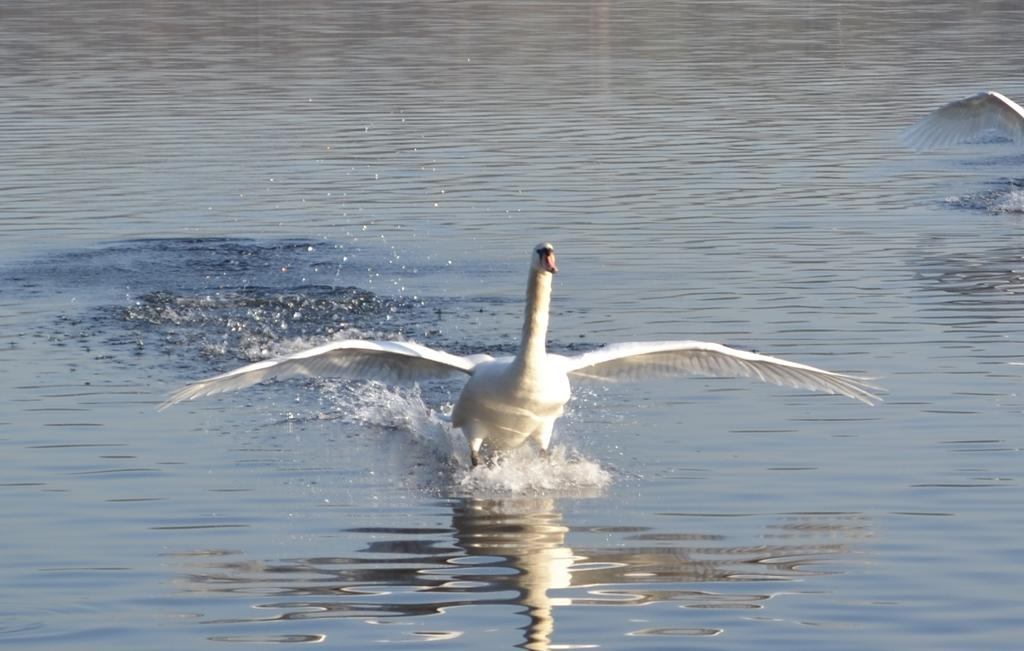What is located in the center of the image? There is a bird in the water in the center of the image. What can be seen on the right side of the image? There is an object on the right side of the image that is white in color. What is visible in the background of the image? There is a sea visible in the background of the image. How many icicles are hanging from the bird's beak in the image? There are no icicles present in the image; it features a bird in the water. What type of beetle can be seen crawling on the white object in the image? There is no beetle present in the image; the white object is not described in detail. 